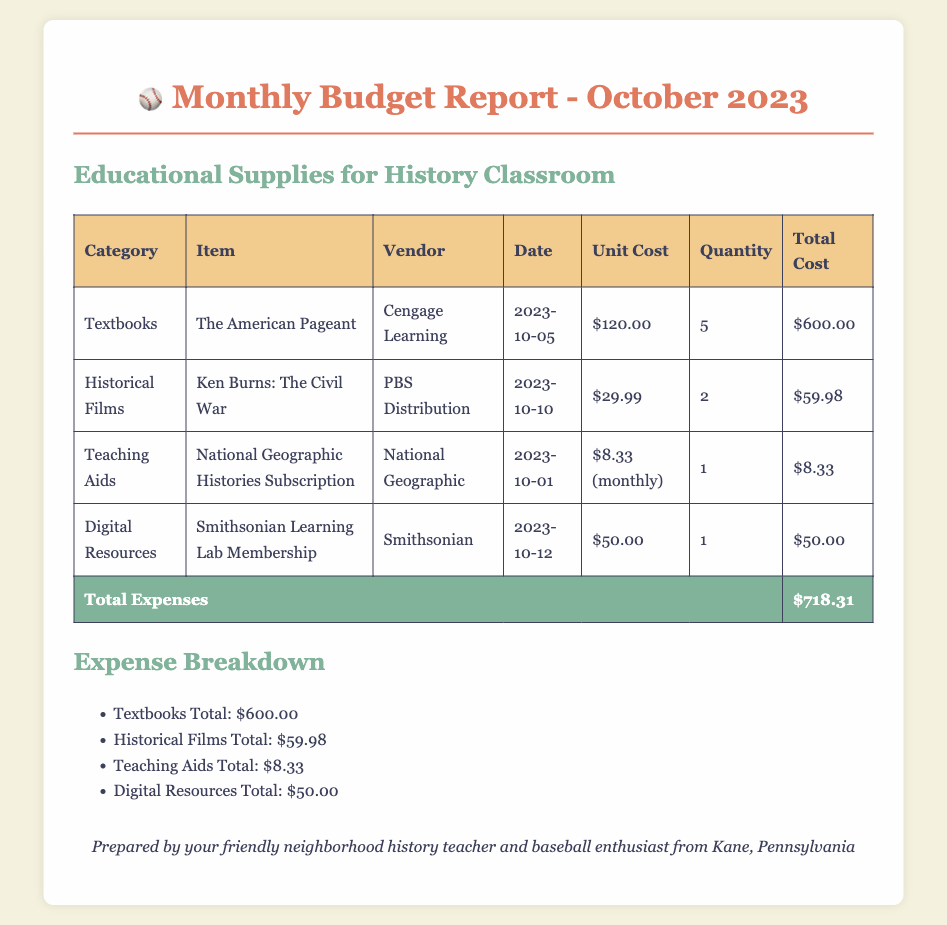What is the total cost of textbooks? The total cost for textbooks is specified in the table under the "Total Cost" column for that category, which is $600.00.
Answer: $600.00 Who is the vendor for the historical films? The vendor for the historical films is mentioned in the table, which states PBS Distribution.
Answer: PBS Distribution When was the National Geographic Histories Subscription purchased? The purchase date for the National Geographic subscription can be found in the "Date" column of the document, which is 2023-10-01.
Answer: 2023-10-01 What is the unit cost of the Smithsonian Learning Lab Membership? The unit cost for the Smithsonian Learning Lab Membership is stated in the table as $50.00.
Answer: $50.00 How much was spent on teaching aids? The total amount spent on teaching aids is listed in the expense breakdown section as $8.33.
Answer: $8.33 What percentage of the total expenses is attributed to textbooks? The total expenses are $718.31, and the textbooks cost $600.00, therefore the percentage is calculated as (600/718.31) * 100 which requires understanding both values.
Answer: 83.4% What type of document is this? The document clearly indicates in the title that it is a Monthly Budget Report.
Answer: Monthly Budget Report Which item costs the least? The items' costs in the table reveal that the teaching aid, National Geographic Histories Subscription, costs the least at $8.33.
Answer: $8.33 